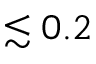<formula> <loc_0><loc_0><loc_500><loc_500>\lesssim 0 . 2</formula> 